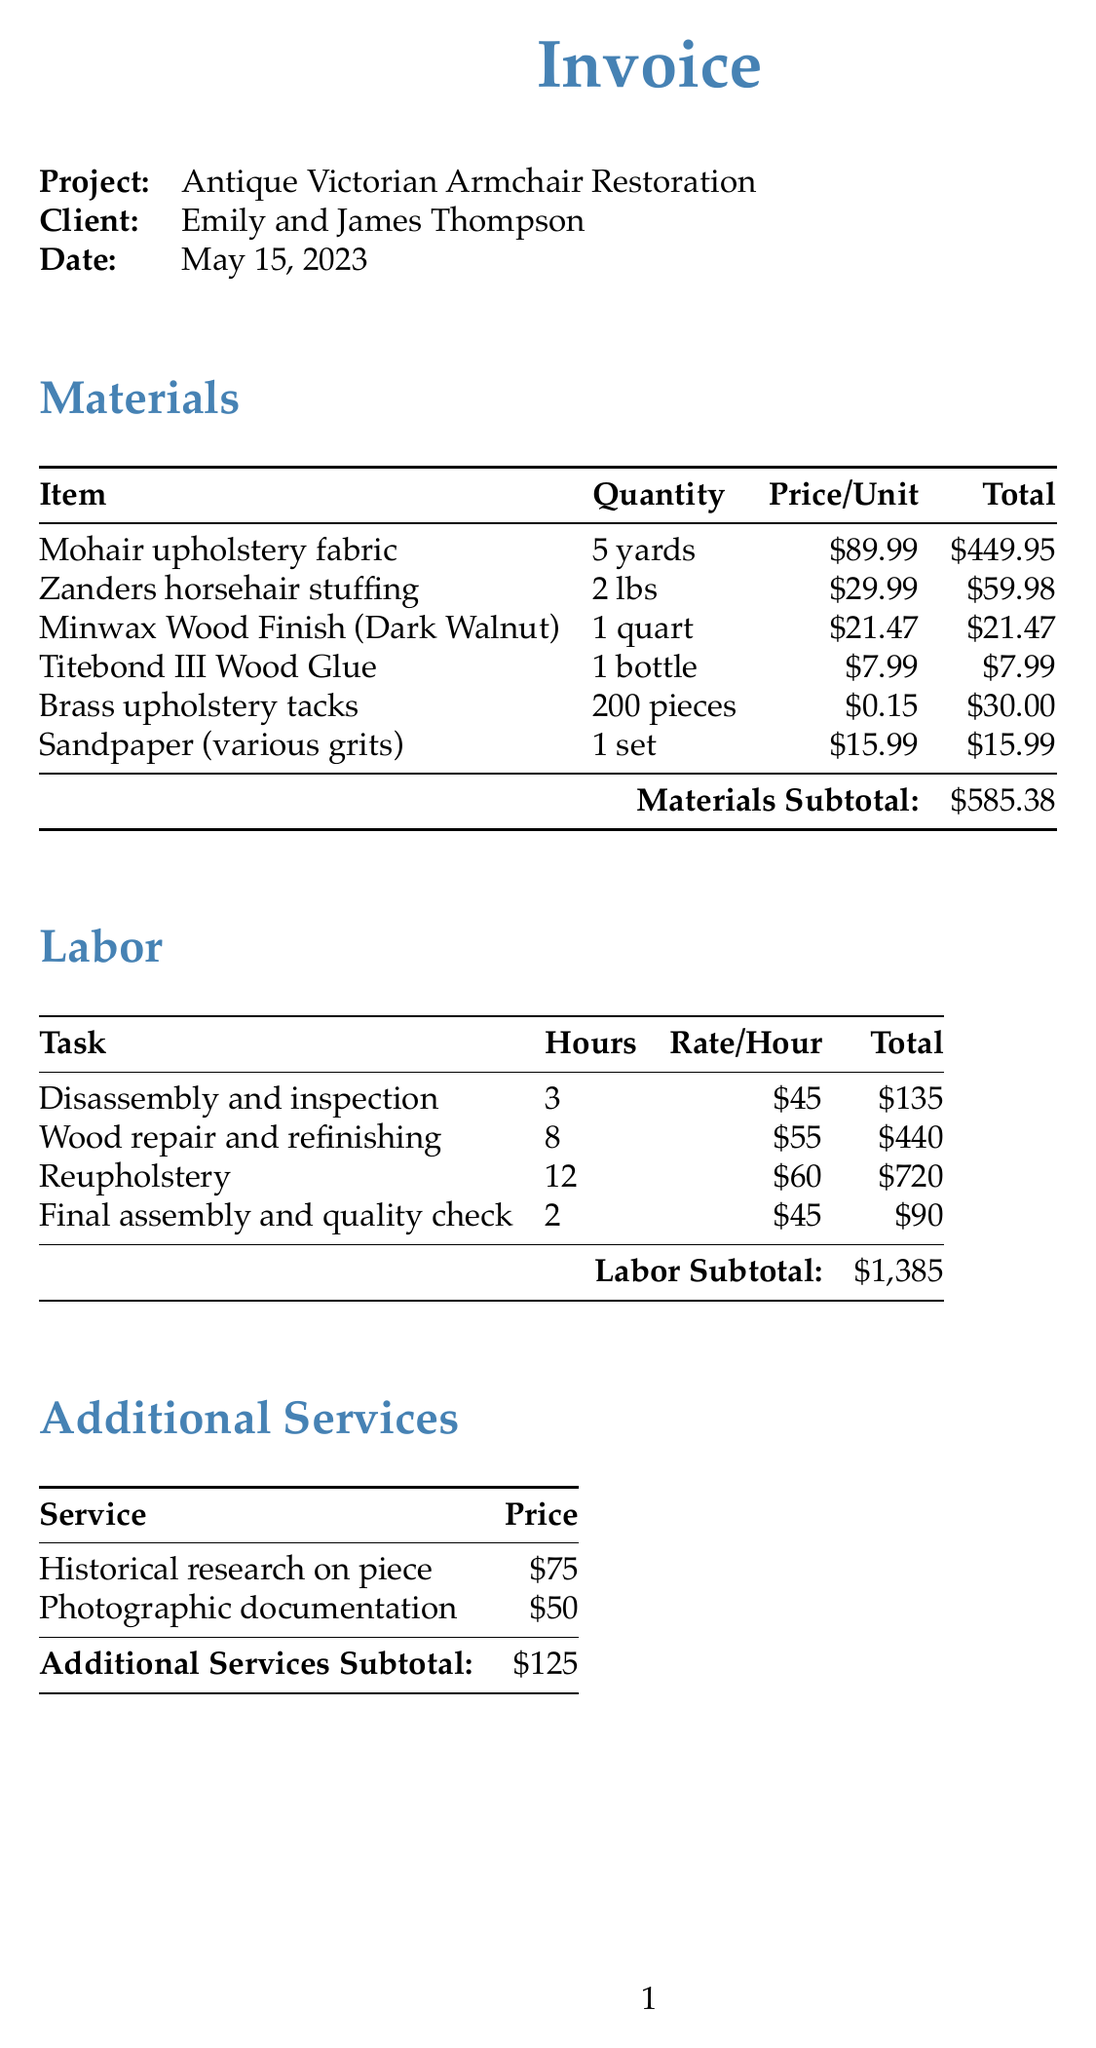What is the project name? The project name is mentioned at the top of the document under 'Project'.
Answer: Antique Victorian Armchair Restoration What is the total cost including tax? The grand total is the final amount including all costs and tax from the totals section.
Answer: $2,263.01 How much did the materials cost in total? The materials subtotal is calculated and presented in the materials section.
Answer: $585.38 What is the hourly rate for reupholstery? The hourly rate for reupholstery is listed in the labor section.
Answer: $60 How many hours were worked on wood repair and refinishing? The number of hours is specified in the labor section for that task.
Answer: 8 What service costs $75? This service cost is noted under additional services.
Answer: Historical research on piece What is the tax rate applied? The tax rate is mentioned in the totals section before calculating the tax amount.
Answer: 8% What type of fabric was used for upholstery? The type of fabric is detailed in the materials section.
Answer: Mohair upholstery fabric What is included in the notes section? The notes section contains specific information about quality and care regarding the restoration.
Answer: All materials used are of the highest quality and period-appropriate 